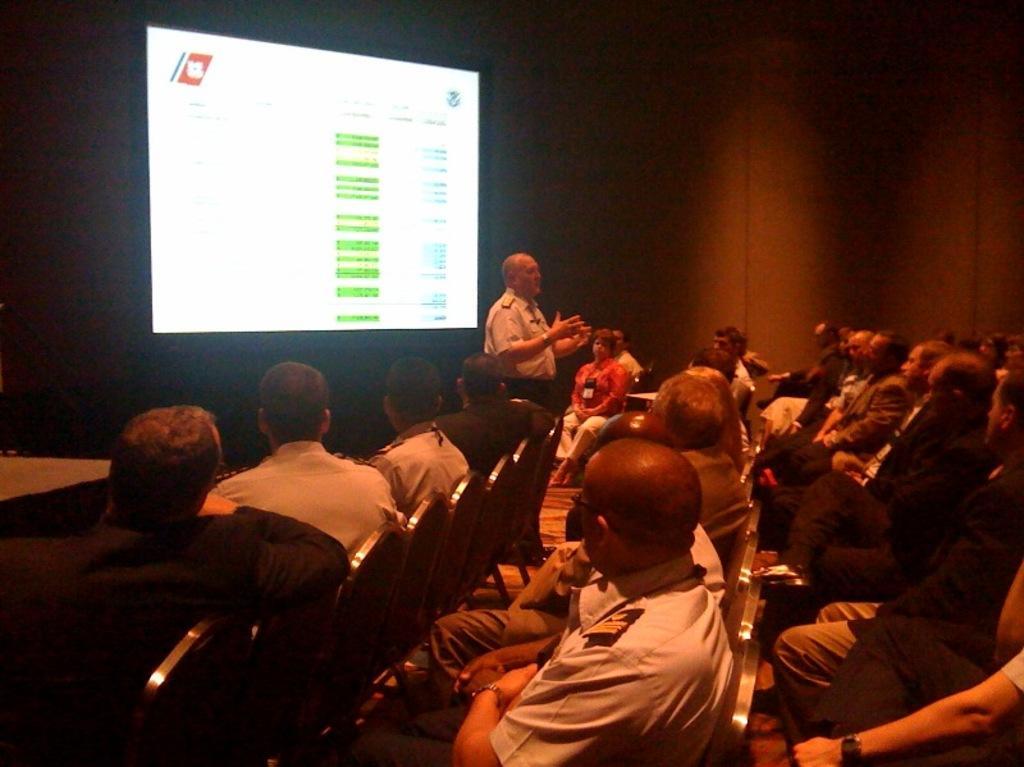In one or two sentences, can you explain what this image depicts? People are sitting on chairs. In-front of this screen a person is standing and looking at these people.  